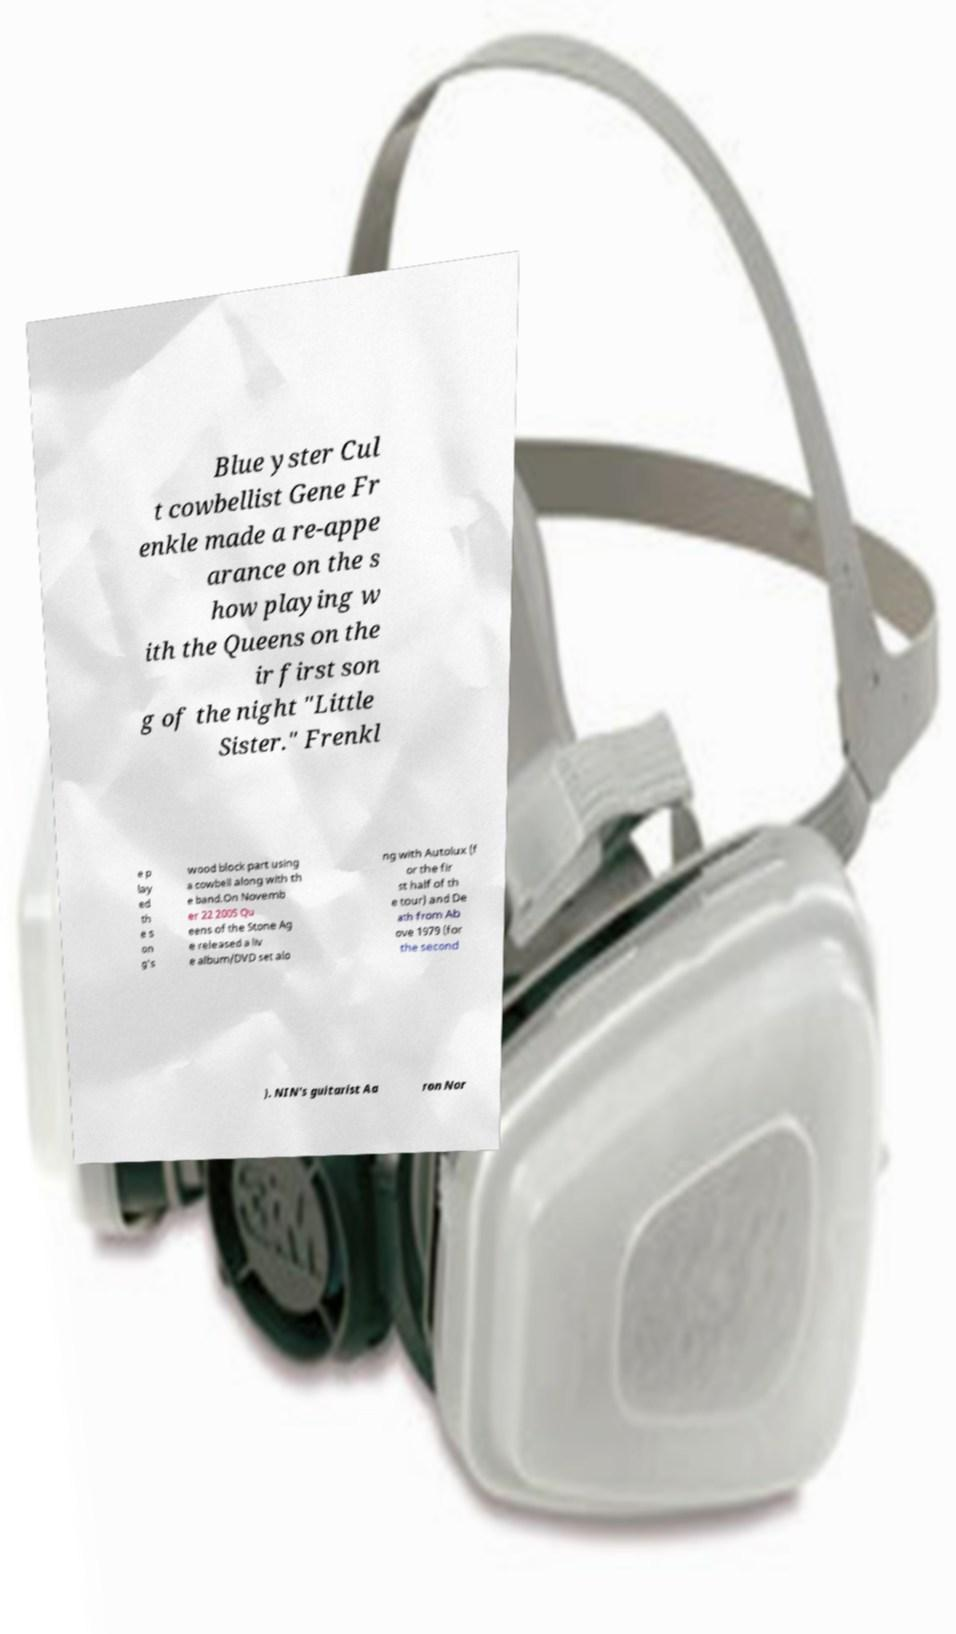Please read and relay the text visible in this image. What does it say? Blue yster Cul t cowbellist Gene Fr enkle made a re-appe arance on the s how playing w ith the Queens on the ir first son g of the night "Little Sister." Frenkl e p lay ed th e s on g's wood block part using a cowbell along with th e band.On Novemb er 22 2005 Qu eens of the Stone Ag e released a liv e album/DVD set alo ng with Autolux (f or the fir st half of th e tour) and De ath from Ab ove 1979 (for the second ). NIN's guitarist Aa ron Nor 